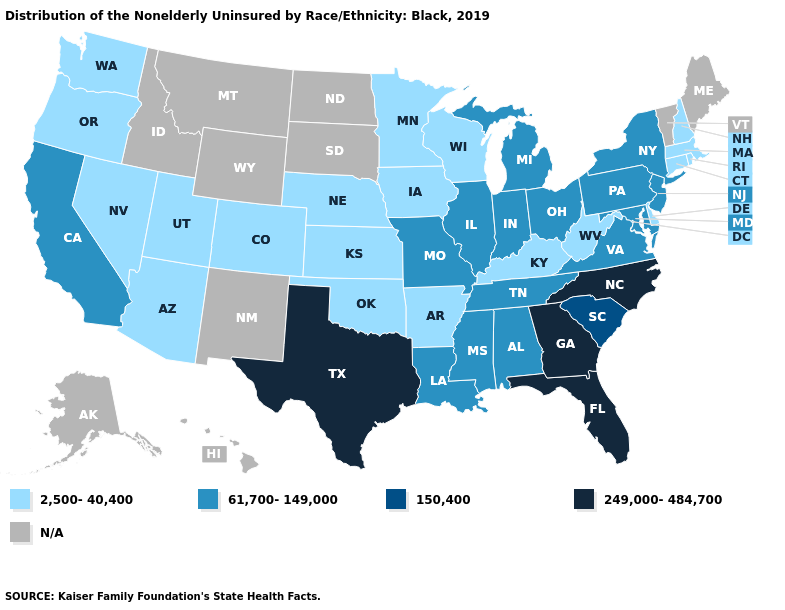Which states hav the highest value in the Northeast?
Quick response, please. New Jersey, New York, Pennsylvania. What is the value of Texas?
Concise answer only. 249,000-484,700. Among the states that border Massachusetts , does New York have the lowest value?
Be succinct. No. What is the value of Wisconsin?
Give a very brief answer. 2,500-40,400. What is the value of Wisconsin?
Write a very short answer. 2,500-40,400. Name the states that have a value in the range N/A?
Be succinct. Alaska, Hawaii, Idaho, Maine, Montana, New Mexico, North Dakota, South Dakota, Vermont, Wyoming. Name the states that have a value in the range 2,500-40,400?
Concise answer only. Arizona, Arkansas, Colorado, Connecticut, Delaware, Iowa, Kansas, Kentucky, Massachusetts, Minnesota, Nebraska, Nevada, New Hampshire, Oklahoma, Oregon, Rhode Island, Utah, Washington, West Virginia, Wisconsin. What is the highest value in the USA?
Write a very short answer. 249,000-484,700. Name the states that have a value in the range 2,500-40,400?
Quick response, please. Arizona, Arkansas, Colorado, Connecticut, Delaware, Iowa, Kansas, Kentucky, Massachusetts, Minnesota, Nebraska, Nevada, New Hampshire, Oklahoma, Oregon, Rhode Island, Utah, Washington, West Virginia, Wisconsin. What is the value of Iowa?
Keep it brief. 2,500-40,400. What is the highest value in states that border Idaho?
Be succinct. 2,500-40,400. Which states have the highest value in the USA?
Short answer required. Florida, Georgia, North Carolina, Texas. Which states have the lowest value in the USA?
Write a very short answer. Arizona, Arkansas, Colorado, Connecticut, Delaware, Iowa, Kansas, Kentucky, Massachusetts, Minnesota, Nebraska, Nevada, New Hampshire, Oklahoma, Oregon, Rhode Island, Utah, Washington, West Virginia, Wisconsin. 